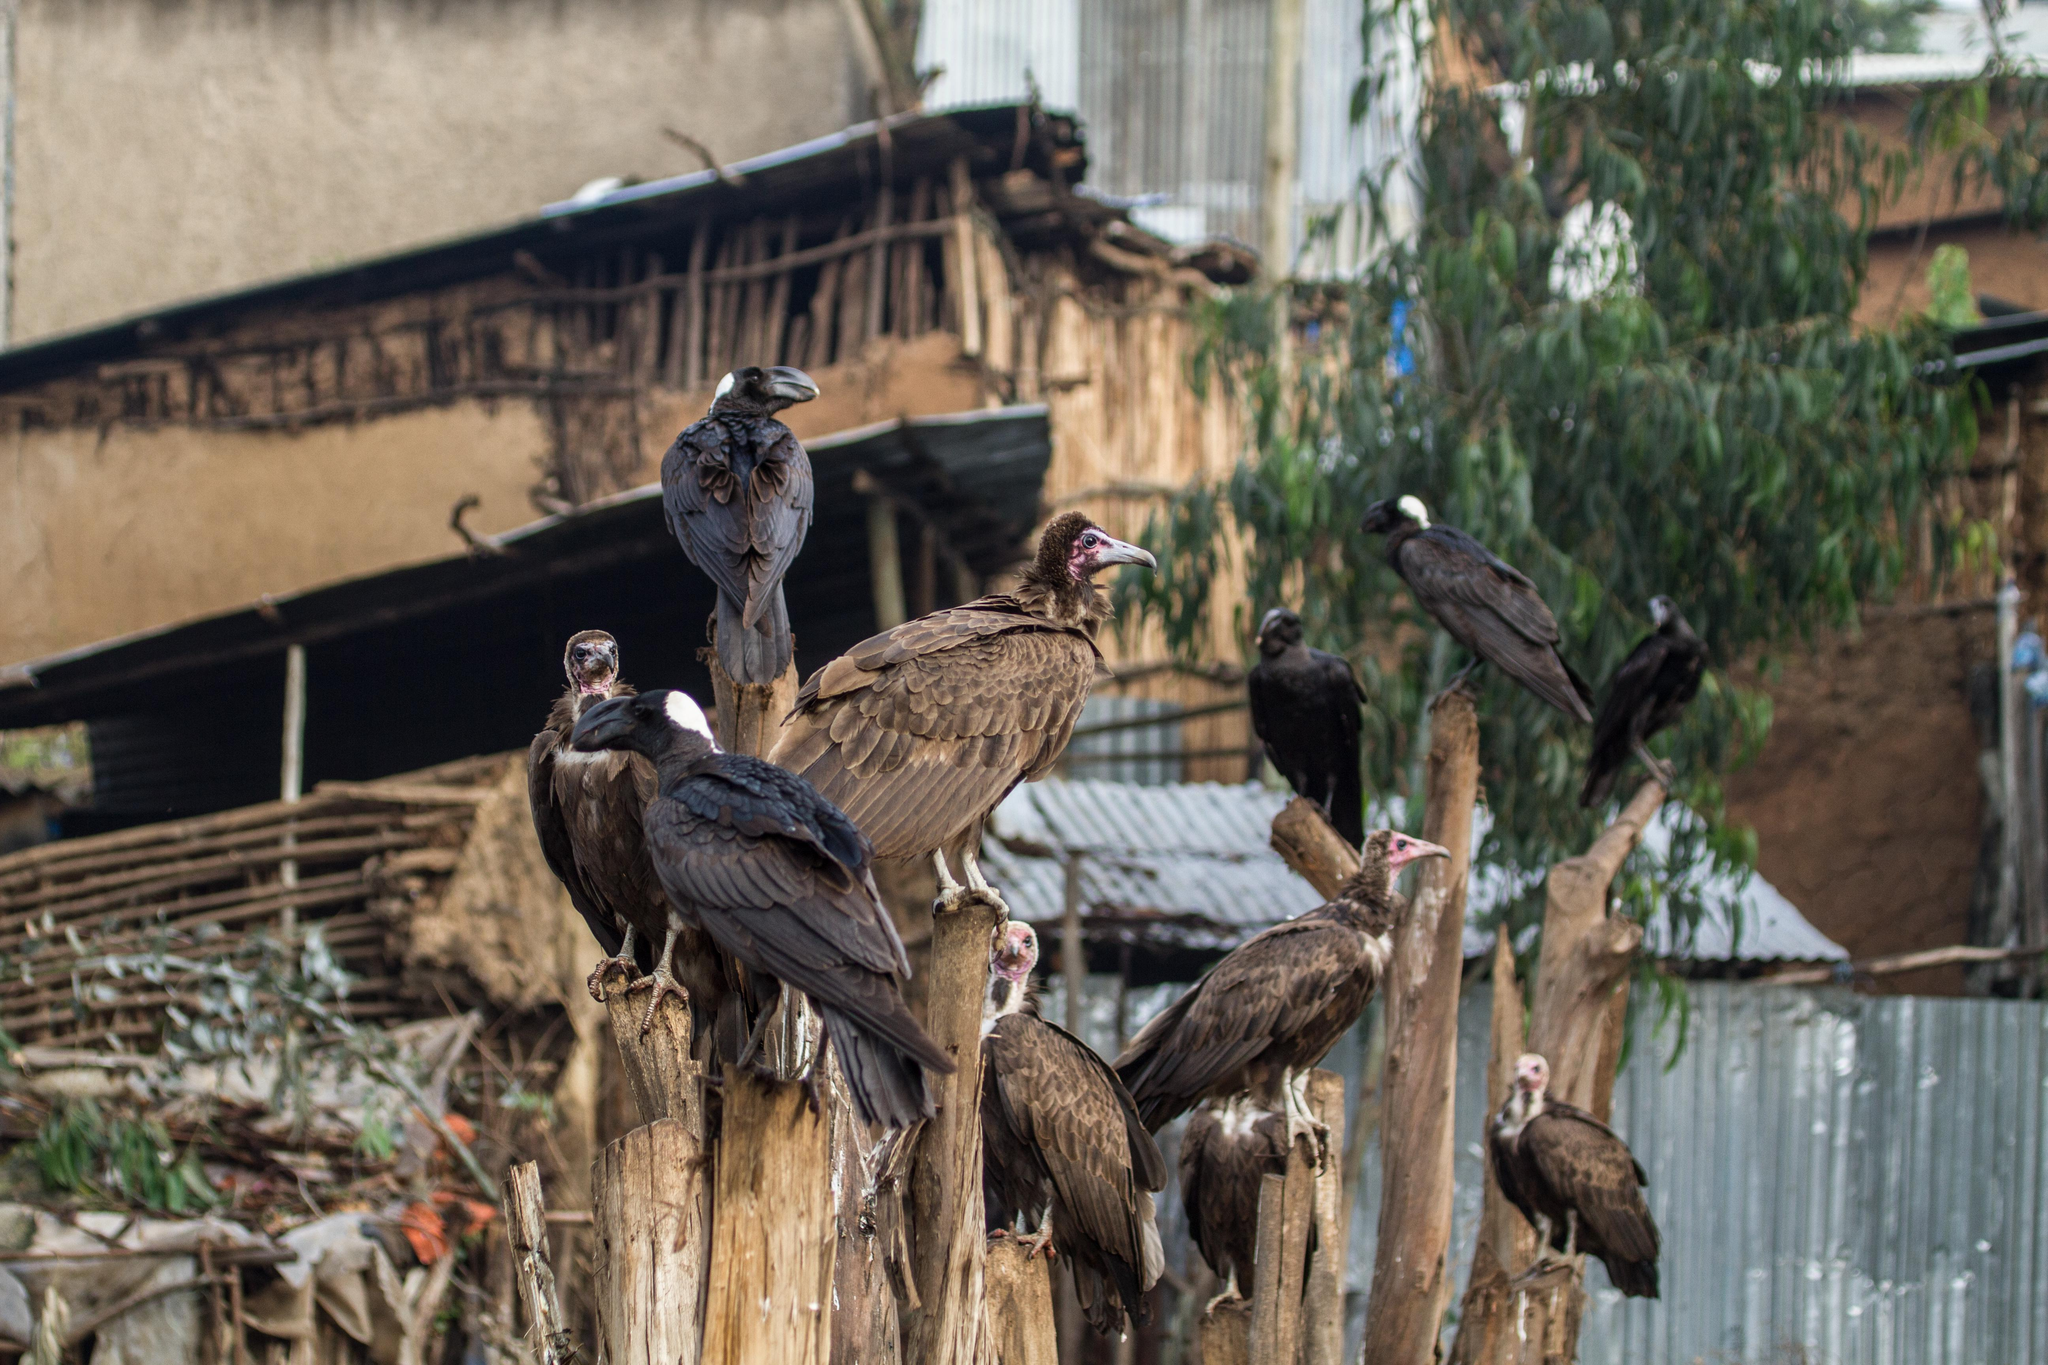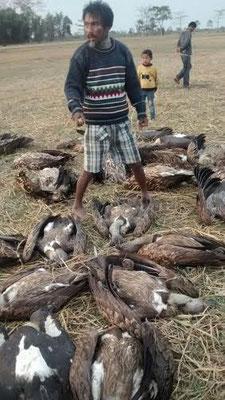The first image is the image on the left, the second image is the image on the right. Assess this claim about the two images: "One of the images shows exactly one bird perched on a branch.". Correct or not? Answer yes or no. No. The first image is the image on the left, the second image is the image on the right. Given the left and right images, does the statement "An image shows one dark bird perched on a horizontal tree branch." hold true? Answer yes or no. No. 